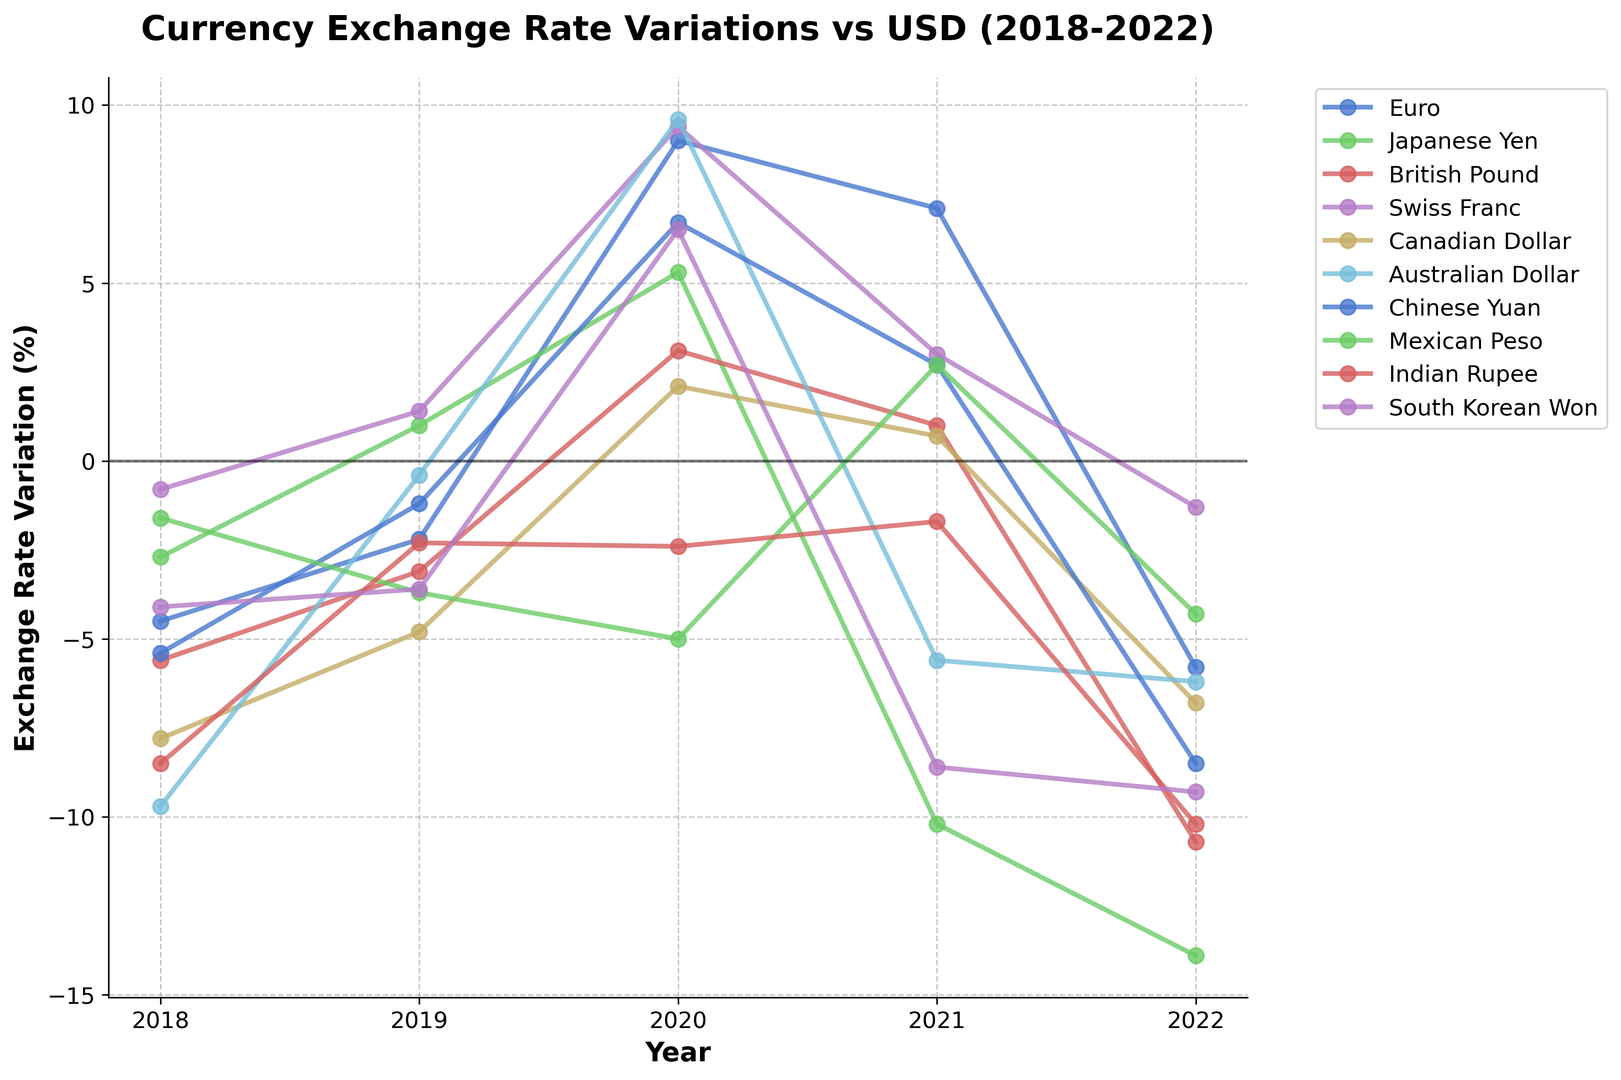What is the overall trend for the Euro from 2018 to 2022? Looking at the Euro line on the chart, it initially shows a negative variation in 2018 and 2019, increases positively in 2020 and 2021, and then drops significantly in 2022. Overall, it shows a fluctuating trend with a final decline in 2022.
Answer: Fluctuating Which currency had the highest positive variation in any single year? By looking at the highest peaks among all the lines in the chart, we observe that the Australian Dollar had the highest positive variation in 2020 with a 9.6% increase.
Answer: Australian Dollar Between the Canadian Dollar and the Swiss Franc, which currency had a steeper decline in 2022? By comparing the slopes of the lines for 2022, the Canadian Dollar shows a steeper negative slope at -6.8%, while the Swiss Franc has a smaller decline at -1.3%. Hence, the Canadian Dollar had a steeper decline.
Answer: Canadian Dollar Which currencies experienced an overall positive change from 2018 to 2022? Reviewing the chart for start and end values of each currency, only the Euro and Swiss Franc had positive values in at least one year, but considering the net change from 2018 to 2022, no currency shows an overall positive change.
Answer: None What is the average exchange rate variation of the British Pound over the 5-year period? Adding up the values for the British Pound over the years: (-5.6) + (-3.1) + 3.1 + 1.0 + (-10.7) = -15.3. Dividing by the number of years (5) gives the average exchange rate variation: -15.3 / 5 = -3.06.
Answer: -3.06 Which currency had the most drastic change in its exchange rate from 2019 to 2020? To identify the most drastic change, look at the differences: Euro: 11.2, Yen: 4.3, Pound: 6.2, Franc: 8.0, Dollar: 6.9, Aussie: 10.0, Yuan: 7.9, Peso: -1.3, Rupee: -0.1, Won: +10.1. The Australian Dollar had the most significant change of 10.0.
Answer: Australian Dollar Which year shows the highest number of currencies with a positive exchange rate variation? Reviewing the chart, the year 2020 shows the highest number of currencies with a positive exchange rate, including Euro, Yen, Pound, Franc, Dollar, Aussie, Yuan, and Won, a total of 8 currencies.
Answer: 2020 